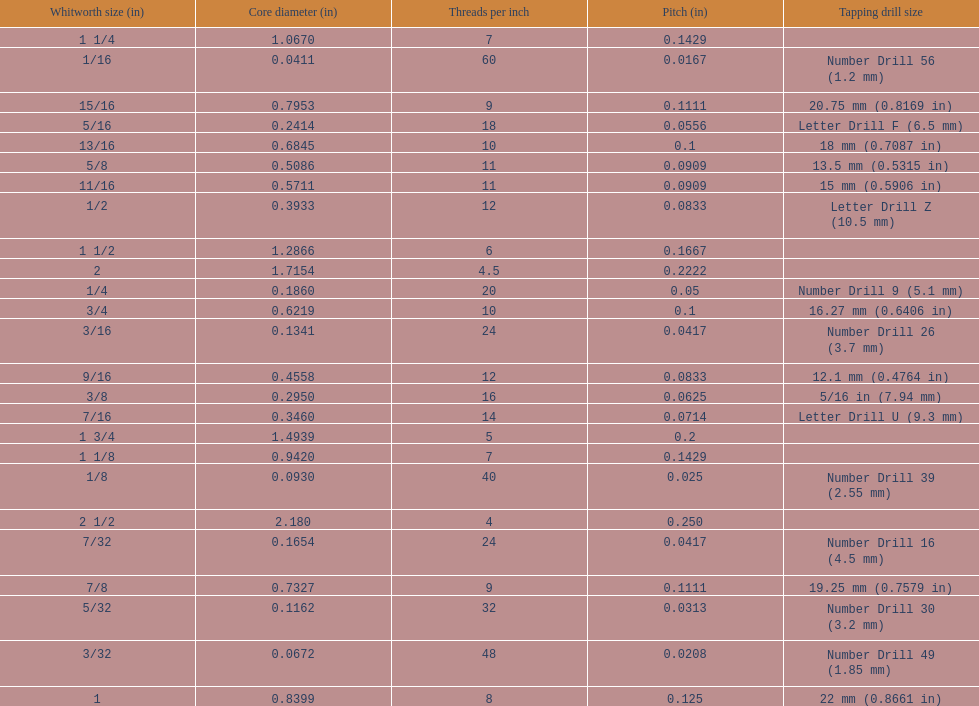What is the top amount of threads per inch? 60. 